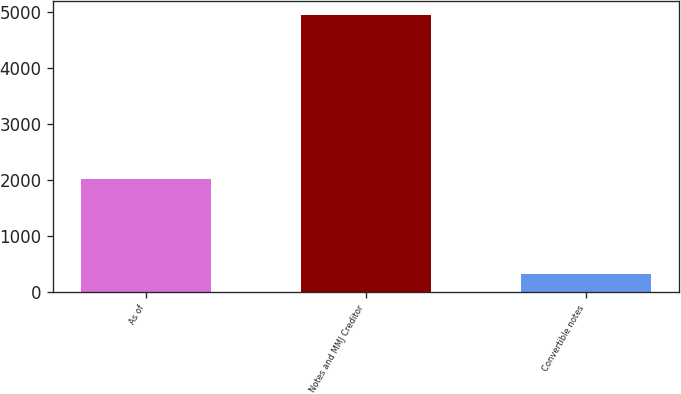Convert chart. <chart><loc_0><loc_0><loc_500><loc_500><bar_chart><fcel>As of<fcel>Notes and MMJ Creditor<fcel>Convertible notes<nl><fcel>2019<fcel>4937<fcel>323<nl></chart> 